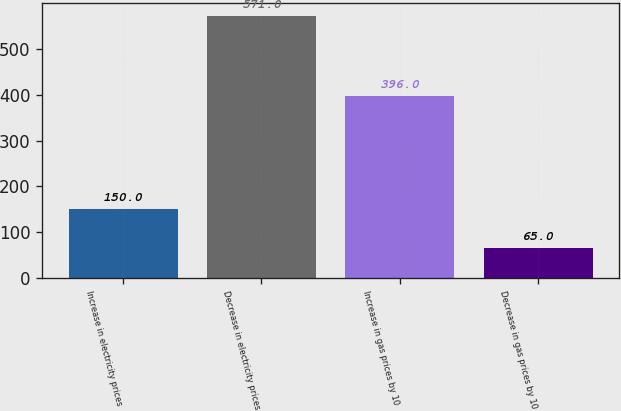Convert chart to OTSL. <chart><loc_0><loc_0><loc_500><loc_500><bar_chart><fcel>Increase in electricity prices<fcel>Decrease in electricity prices<fcel>Increase in gas prices by 10<fcel>Decrease in gas prices by 10<nl><fcel>150<fcel>571<fcel>396<fcel>65<nl></chart> 